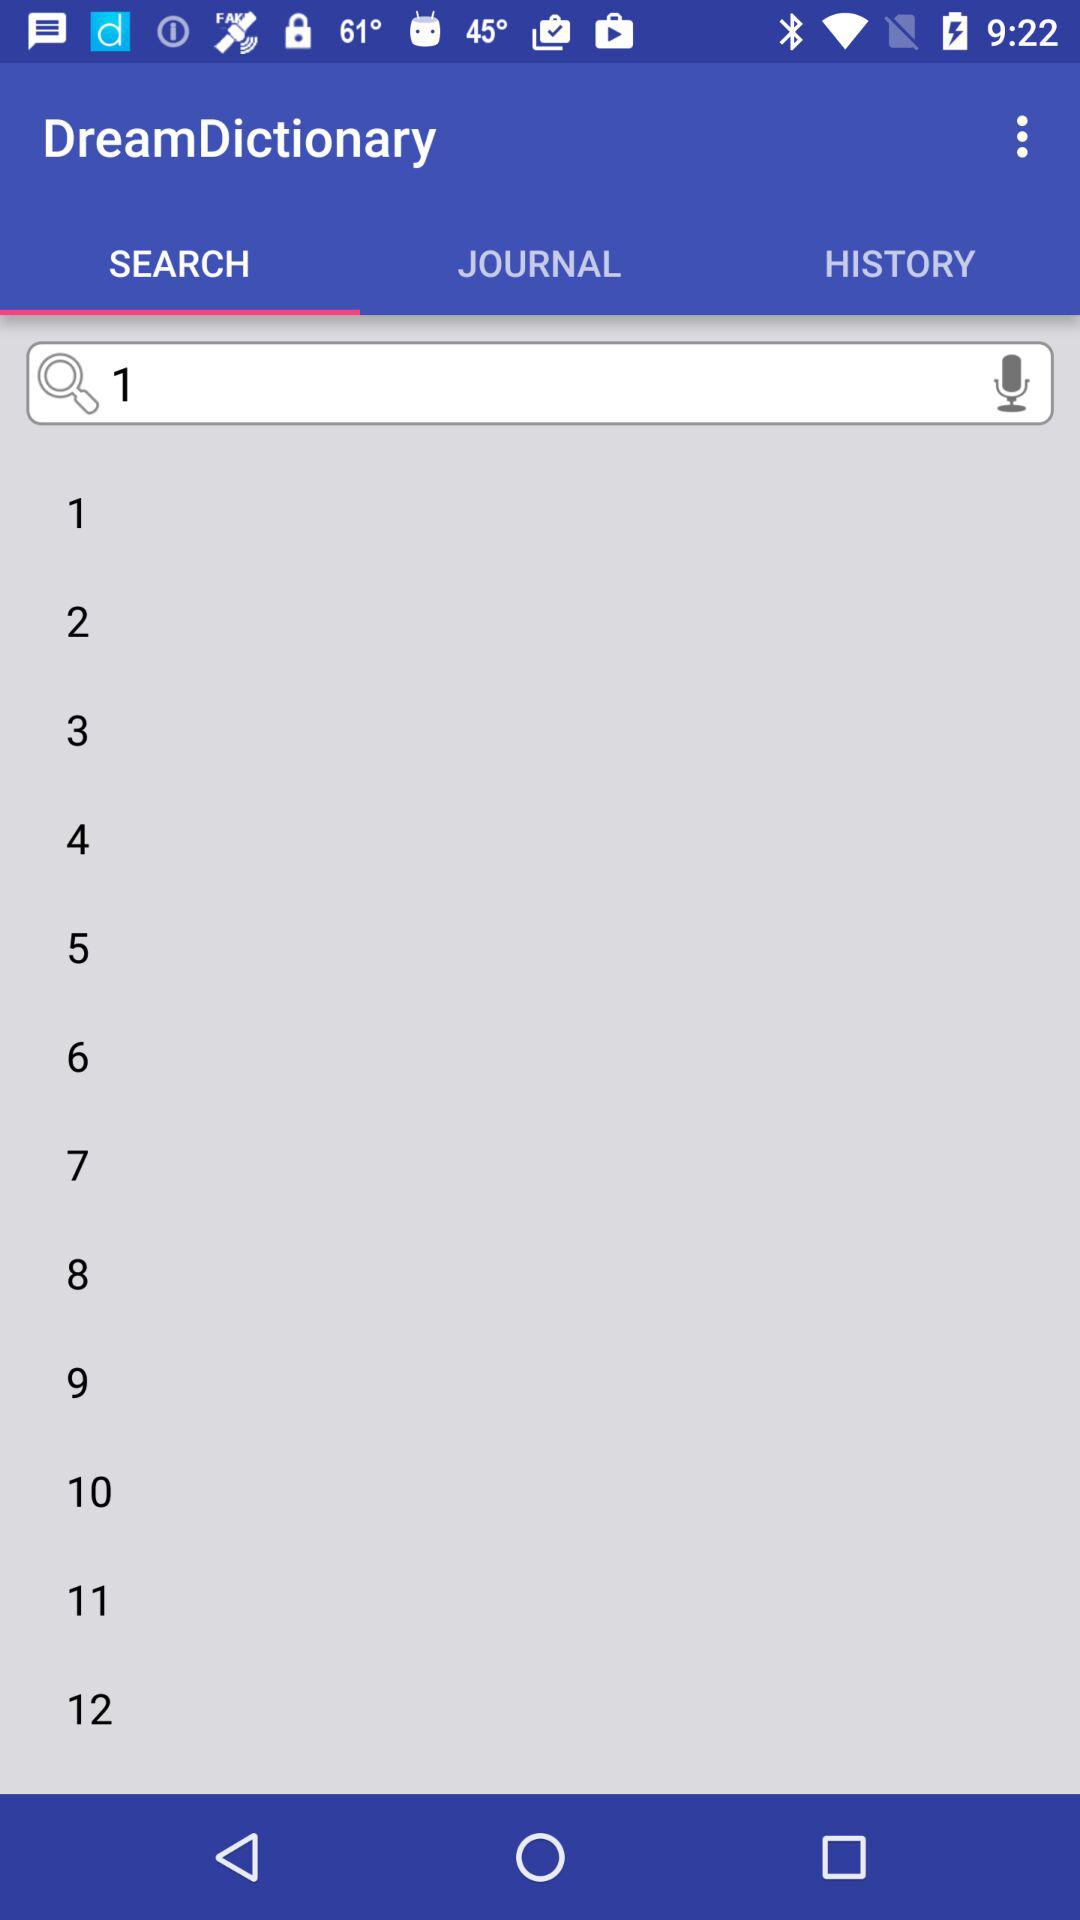Which tab is selected? The selected tab is "SEARCH". 